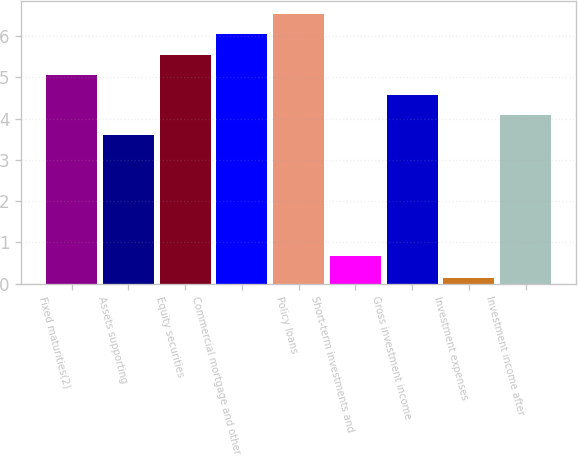Convert chart to OTSL. <chart><loc_0><loc_0><loc_500><loc_500><bar_chart><fcel>Fixed maturities(2)<fcel>Assets supporting<fcel>Equity securities<fcel>Commercial mortgage and other<fcel>Policy loans<fcel>Short-term investments and<fcel>Gross investment income<fcel>Investment expenses<fcel>Investment income after<nl><fcel>5.06<fcel>3.59<fcel>5.55<fcel>6.04<fcel>6.53<fcel>0.68<fcel>4.57<fcel>0.14<fcel>4.08<nl></chart> 